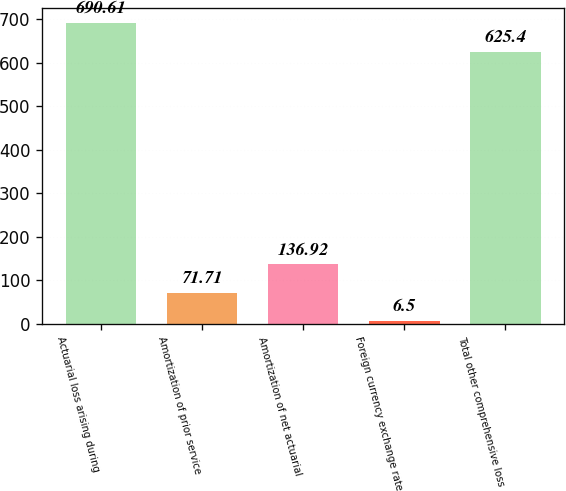<chart> <loc_0><loc_0><loc_500><loc_500><bar_chart><fcel>Actuarial loss arising during<fcel>Amortization of prior service<fcel>Amortization of net actuarial<fcel>Foreign currency exchange rate<fcel>Total other comprehensive loss<nl><fcel>690.61<fcel>71.71<fcel>136.92<fcel>6.5<fcel>625.4<nl></chart> 